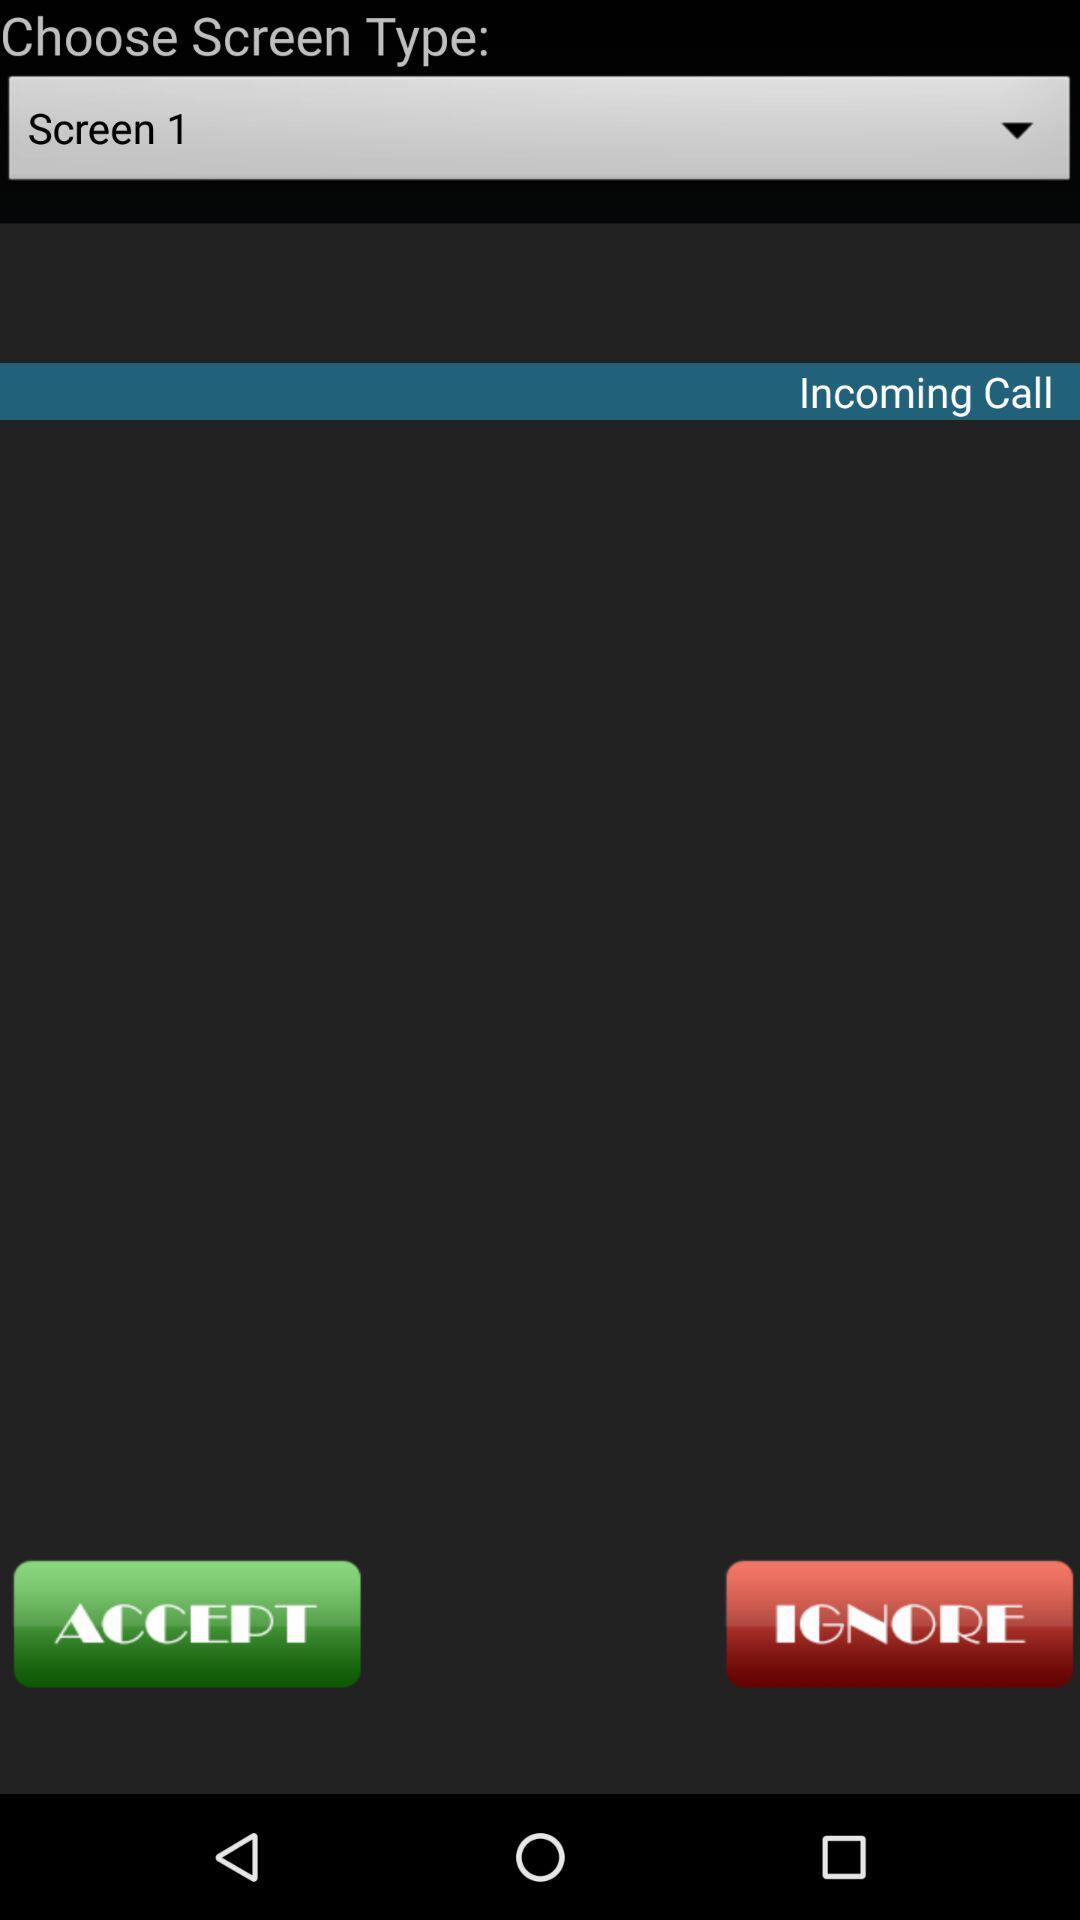Which screen type is chosen? The chosen screen type is "Screen 1". 